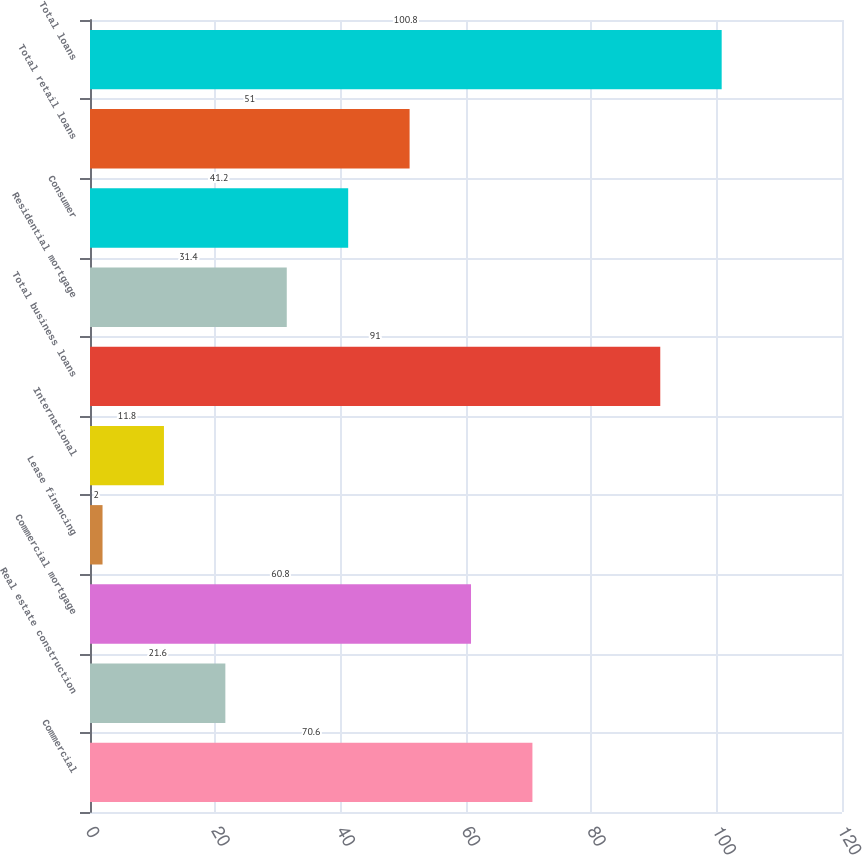Convert chart. <chart><loc_0><loc_0><loc_500><loc_500><bar_chart><fcel>Commercial<fcel>Real estate construction<fcel>Commercial mortgage<fcel>Lease financing<fcel>International<fcel>Total business loans<fcel>Residential mortgage<fcel>Consumer<fcel>Total retail loans<fcel>Total loans<nl><fcel>70.6<fcel>21.6<fcel>60.8<fcel>2<fcel>11.8<fcel>91<fcel>31.4<fcel>41.2<fcel>51<fcel>100.8<nl></chart> 